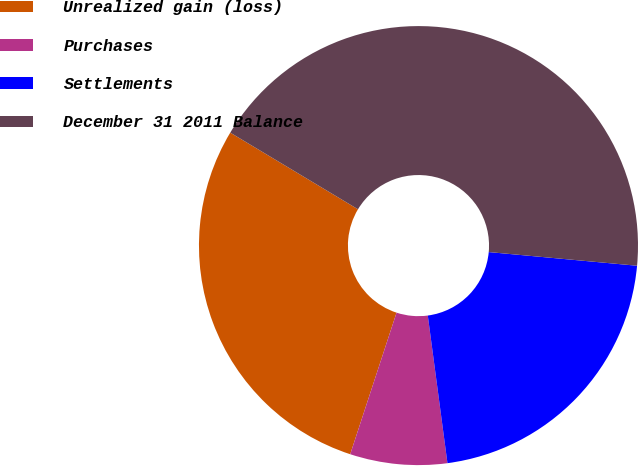<chart> <loc_0><loc_0><loc_500><loc_500><pie_chart><fcel>Unrealized gain (loss)<fcel>Purchases<fcel>Settlements<fcel>December 31 2011 Balance<nl><fcel>28.57%<fcel>7.14%<fcel>21.43%<fcel>42.86%<nl></chart> 